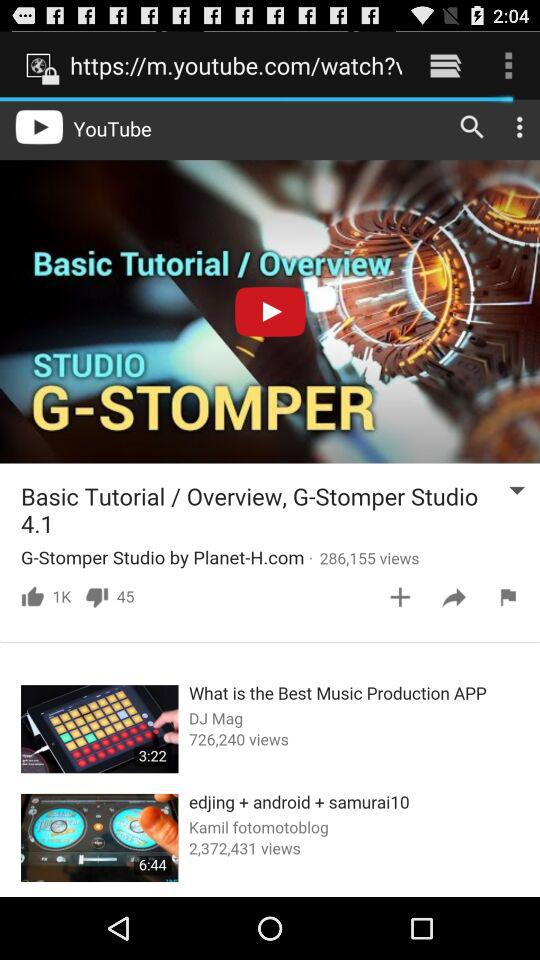How long is the "What is the best music production" video? The video "What is the best music production" is 3 minutes and 22 seconds long. 